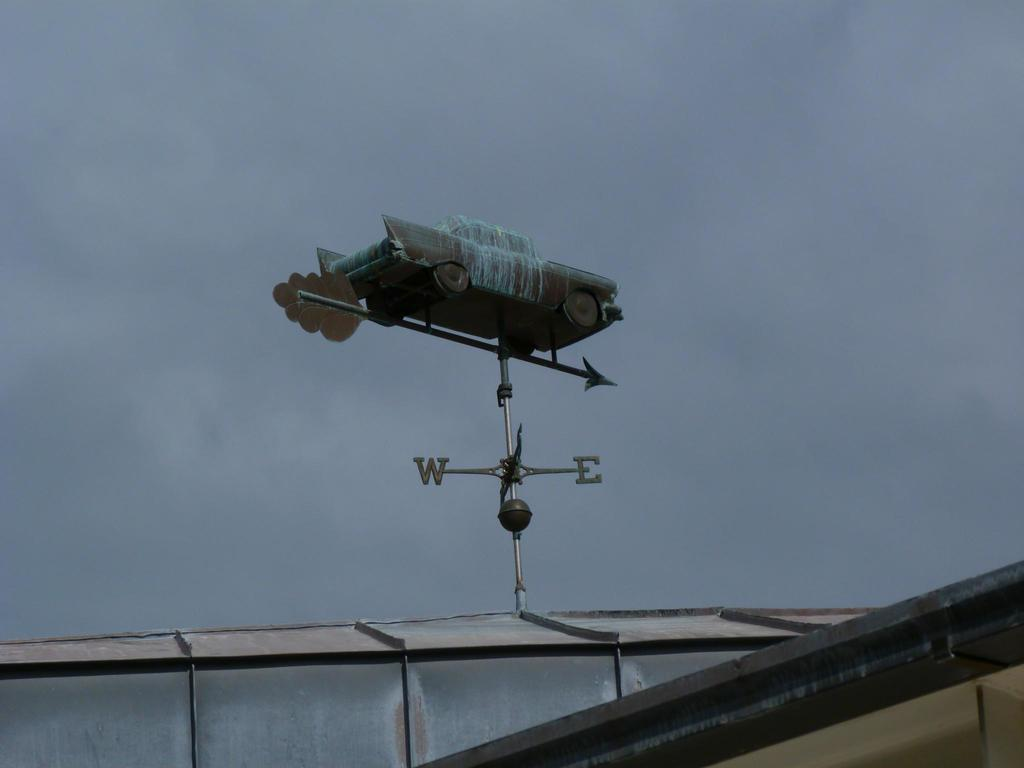<image>
Present a compact description of the photo's key features. A weather vane has directional arrow for the Western direction and the Eastern direction. 